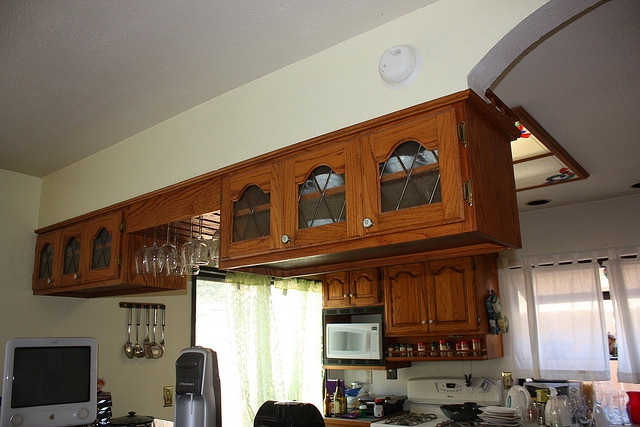Describe the objects in this image and their specific colors. I can see tv in gray and black tones, oven in gray and black tones, microwave in gray, darkgray, beige, and lightgray tones, oven in gray, black, and darkgray tones, and wine glass in gray, maroon, and black tones in this image. 